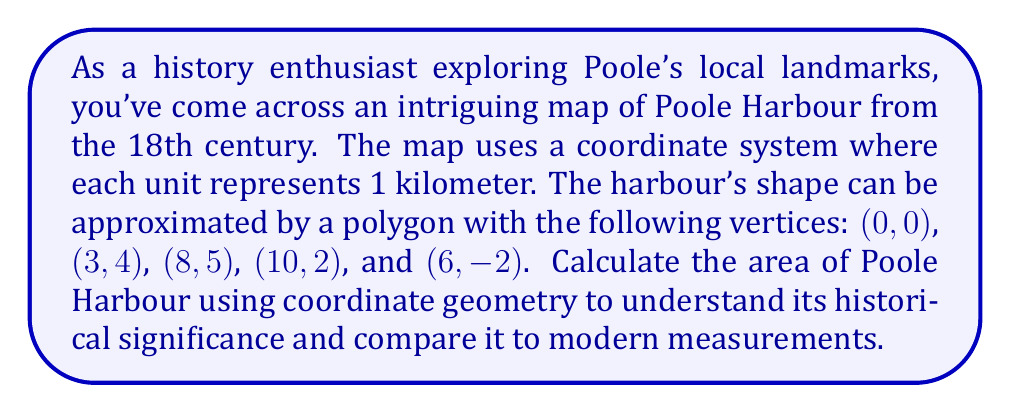Could you help me with this problem? To calculate the area of Poole Harbour using coordinate geometry, we'll use the Shoelace formula (also known as the surveyor's formula). This method is particularly useful for calculating the area of an irregular polygon given its vertices.

The Shoelace formula is:

$$ A = \frac{1}{2}|\sum_{i=1}^{n-1} (x_iy_{i+1} + x_ny_1) - \sum_{i=1}^{n-1} (y_ix_{i+1} + y_nx_1)| $$

Where $(x_i, y_i)$ are the coordinates of the $i$-th vertex, and $n$ is the number of vertices.

Let's apply this formula to our polygon:

1) First, let's list our vertices in order:
   $(x_1, y_1) = (0, 0)$
   $(x_2, y_2) = (3, 4)$
   $(x_3, y_3) = (8, 5)$
   $(x_4, y_4) = (10, 2)$
   $(x_5, y_5) = (6, -2)$

2) Now, let's calculate the first sum:
   $\sum_{i=1}^{n-1} (x_iy_{i+1} + x_ny_1)$
   $= (0 \cdot 4) + (3 \cdot 5) + (8 \cdot 2) + (10 \cdot -2) + (6 \cdot 0)$
   $= 0 + 15 + 16 - 20 + 0 = 11$

3) Next, calculate the second sum:
   $\sum_{i=1}^{n-1} (y_ix_{i+1} + y_nx_1)$
   $= (0 \cdot 3) + (4 \cdot 8) + (5 \cdot 10) + (2 \cdot 6) + (-2 \cdot 0)$
   $= 0 + 32 + 50 + 12 + 0 = 94$

4) Subtract the second sum from the first:
   $11 - 94 = -83$

5) Take the absolute value and divide by 2:
   $\frac{1}{2}|-83| = \frac{83}{2} = 41.5$

Therefore, the area of Poole Harbour based on this historical map is 41.5 square kilometers.
Answer: The area of Poole Harbour is 41.5 square kilometers. 